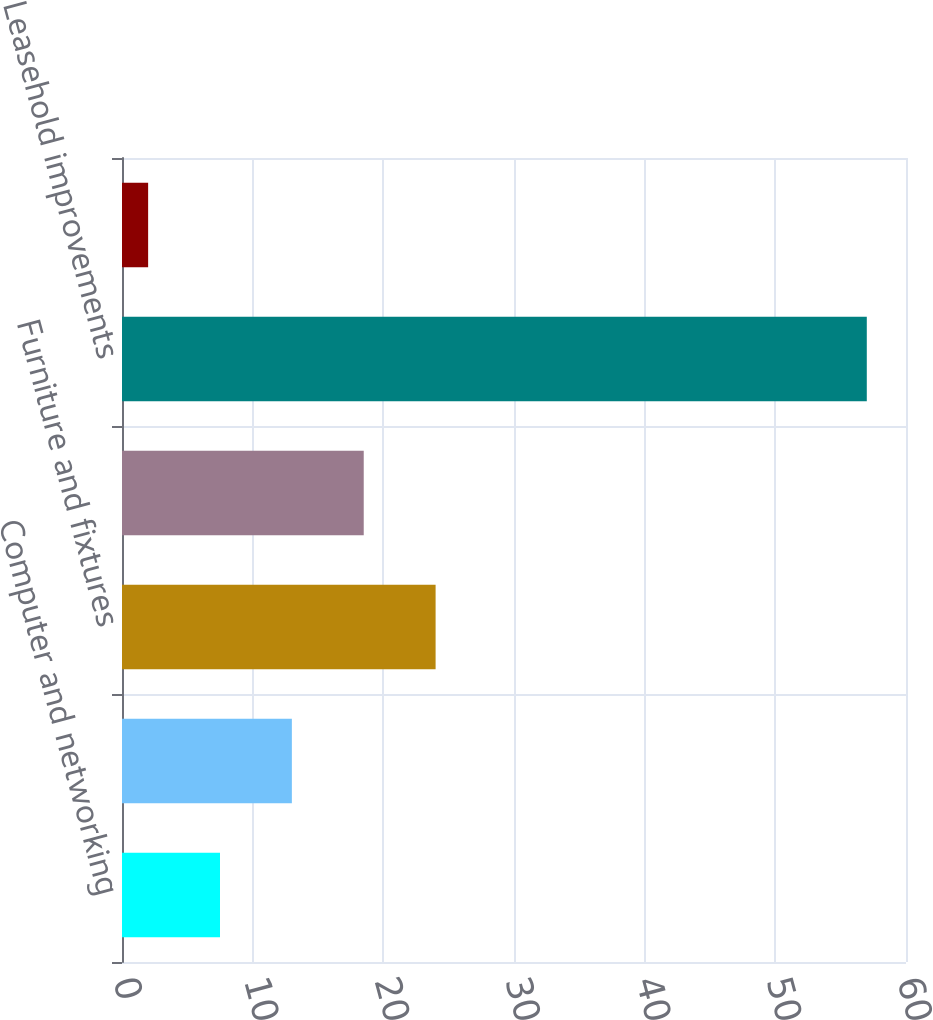Convert chart. <chart><loc_0><loc_0><loc_500><loc_500><bar_chart><fcel>Computer and networking<fcel>Purchased software<fcel>Furniture and fixtures<fcel>Office equipment<fcel>Leasehold improvements<fcel>Internal-use software<nl><fcel>7.5<fcel>13<fcel>24<fcel>18.5<fcel>57<fcel>2<nl></chart> 